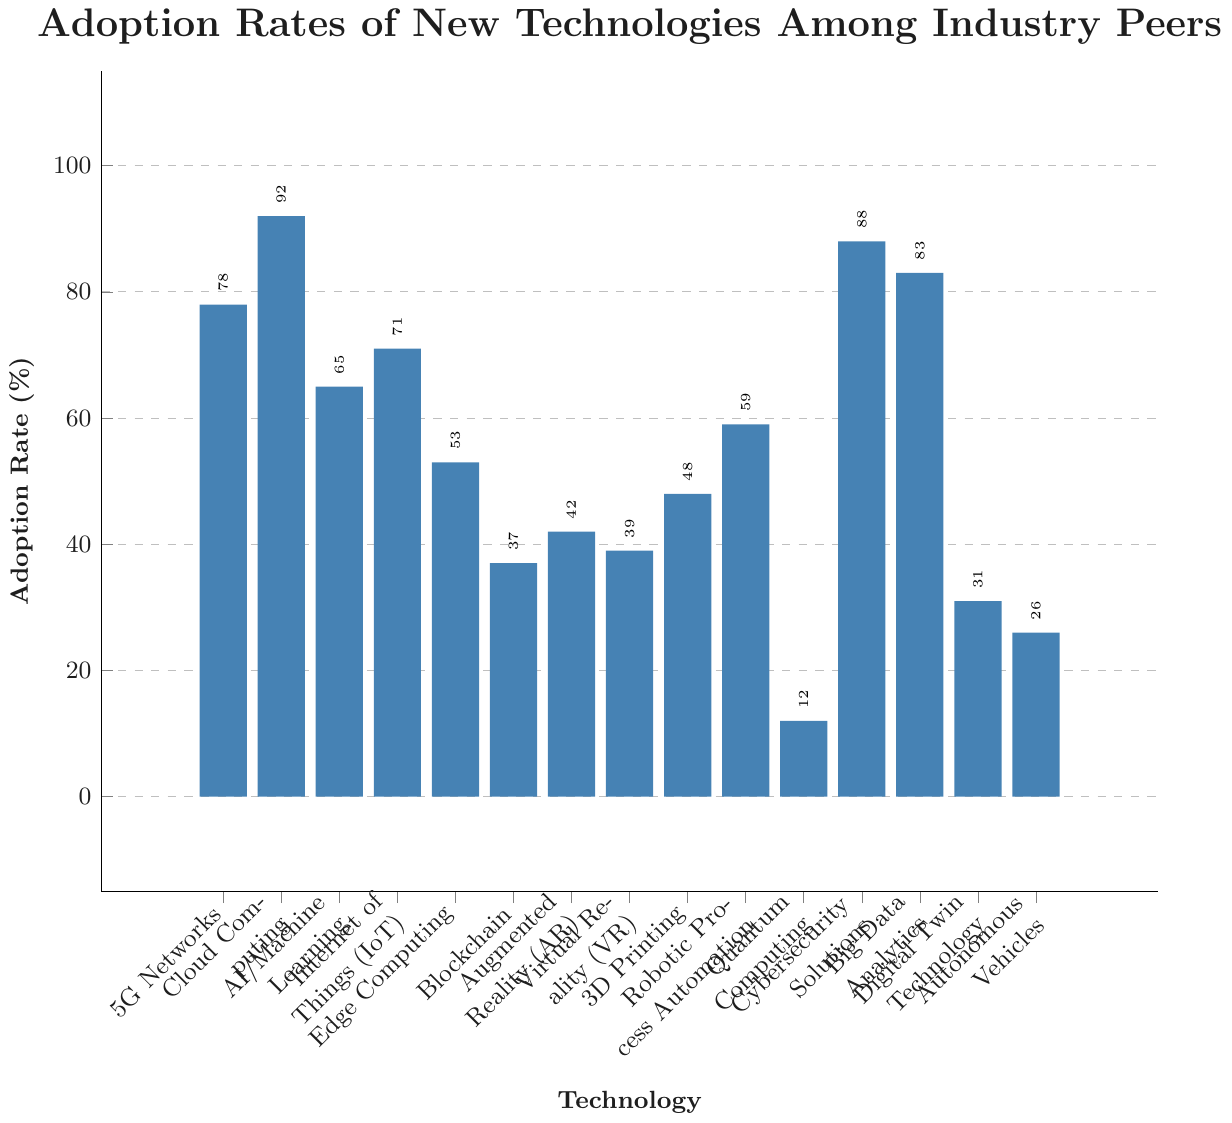How many technologies have an adoption rate greater than 50%? To determine the number of technologies with an adoption rate greater than 50%, count the bars in the figure that extend above the 50% mark. Upon visual inspection, these technologies are: 5G Networks, Cloud Computing, AI/Machine Learning, Internet of Things (IoT), Edge Computing, Cybersecurity Solutions, Big Data Analytics, and Robotic Process Automation. This totals to 8 technologies.
Answer: 8 Which technology has the lowest adoption rate, and what is its value? To find the technology with the lowest adoption rate, look for the shortest bar in the figure. The shortest bar represents Quantum Computing with an adoption rate of 12%.
Answer: Quantum Computing, 12% What is the difference in adoption rates between Cloud Computing and Blockchain? First, locate the bars for Cloud Computing (92%) and Blockchain (37%). Subtract the adoption rate of Blockchain from Cloud Computing: 92 - 37 = 55.
Answer: 55% Which two technologies have the closest adoption rates, and what are those rates? Look for pairs of bars with similar heights by visual inspection. Augmented Reality (42%) and Virtual Reality (39%) have the closest adoption rates. Their difference is only 42 - 39 = 3.
Answer: Augmented Reality (42%), Virtual Reality (39%) What is the average adoption rate of Cloud Computing, AI/Machine Learning, and Blockchain? Locate the adoption rates for Cloud Computing (92%), AI/Machine Learning (65%), and Blockchain (37%). Sum these values: 92 + 65 + 37 = 194. Then, divide by the number of technologies: 194 / 3 = 64.67.
Answer: 64.67% Which technology has a higher adoption rate, Digital Twin Technology or Autonomous Vehicles? Compare the heights of the bars for Digital Twin Technology (31%) and Autonomous Vehicles (26%). The bar for Digital Twin Technology is higher.
Answer: Digital Twin Technology Which technologies have adoption rates between 30% and 50%, inclusive? Identify the bars that fall in the 30%-50% range. These are Edge Computing (53%), Blockchain (37%), Augmented Reality (42%), Virtual Reality (39%), 3D Printing (48%), and Digital Twin Technology (31%). Exclude Edge Computing since it exceeds 50%.
Answer: Blockchain, Augmented Reality, Virtual Reality, 3D Printing, Digital Twin Technology What is the sum of the adoption rates for 3D Printing and Robotic Process Automation? Locate the bars and their adoption rates for 3D Printing (48%) and Robotic Process Automation (59%). Add these values together: 48 + 59 = 107.
Answer: 107 Which technology has a higher adoption rate than AI/Machine Learning but lower than Big Data Analytics? Firstly, identify the adoption rates for AI/Machine Learning (65%) and Big Data Analytics (83%). Find the bars that fall into this range. The only technology that fits this criterion is Internet of Things (IoT) with 71%.
Answer: Internet of Things (IoT) How many technologies have adoption rates lower than 40%, and which are they? Identify the bars lower than the 40% mark. These are Blockchain (37%), Augmented Reality (42%), Virtual Reality (39%), Digital Twin Technology (31%), and Autonomous Vehicles (26%). Exclude Augmented Reality since it exceeds 40%. This results in four technologies.
Answer: Quantum Computing, Blockchain, Virtual Reality, Digital Twin Technology, Autonomous Vehicles 